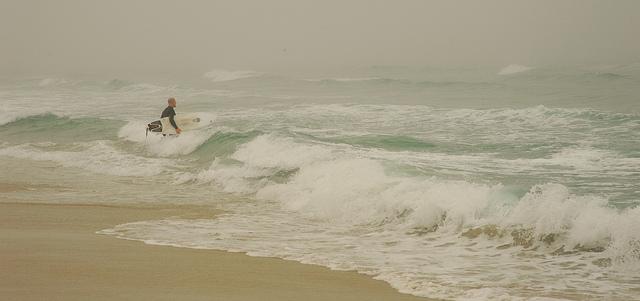Are the waves high?
Give a very brief answer. Yes. Is the water shown drinkable by the unprepared human?
Keep it brief. No. Why is the paddle board in the air?
Short answer required. He fell. Is the sky clear?
Answer briefly. No. 